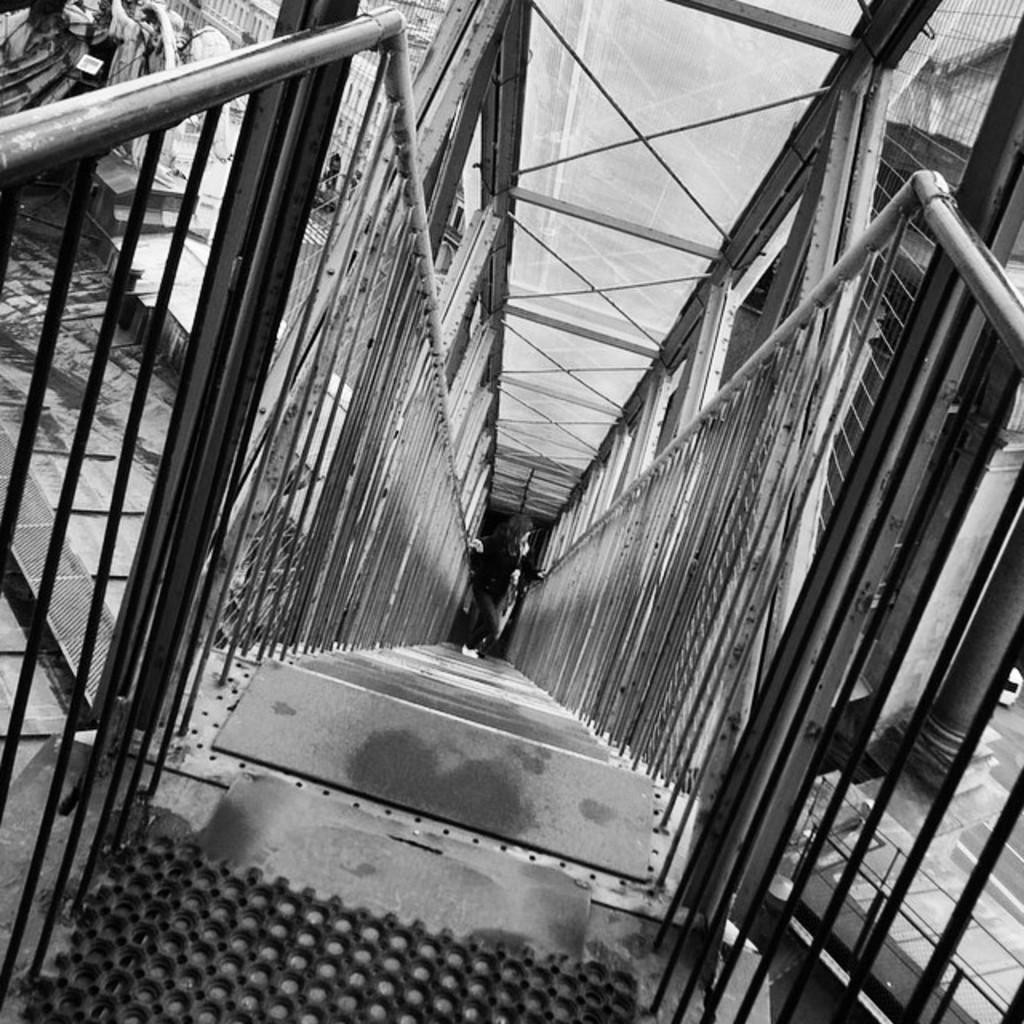What is the color scheme of the image? The image is black and white. What can be seen in the image besides the person? There are steps, rods, and a path visible in the background. What is the person wearing that is noteworthy? The person is wearing transparent glasses. How does the person in the image change the friction of the rods? There is no indication in the image that the person is interacting with the rods or affecting their friction. --- Facts: 1. There is a car in the image. 2. The car is red. 3. The car has four wheels. 4. There is a road in the image. 5. The road is paved. Absurd Topics: parrot, ocean, dance Conversation: What is the main subject of the image? The main subject of the image is a car. What color is the car? The car is red. How many wheels does the car have? The car has four wheels. What type of surface is visible in the image? There is a road in the image, and it is paved. Reasoning: Let's think step by step in order to produce the conversation. We start by identifying the main subject of the image, which is the car. Then, we describe specific details about the car, such as its color and the number of wheels it has. Finally, we focus on the setting in which the car is located, which is a paved road. Absurd Question/Answer: Can you see a parrot flying over the ocean in the image? There is no parrot or ocean present in the image; it features a red car on a paved road. Is there any dancing happening in the image? There is no dancing or indication of any movement in the image; it is a still shot of a red car on a paved road. 